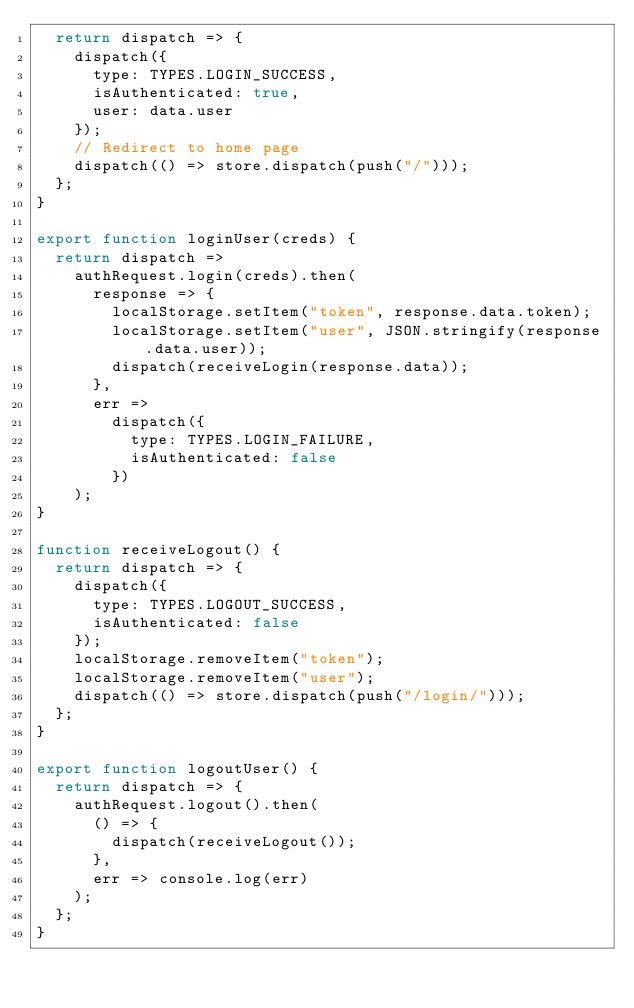<code> <loc_0><loc_0><loc_500><loc_500><_JavaScript_>  return dispatch => {
    dispatch({
      type: TYPES.LOGIN_SUCCESS,
      isAuthenticated: true,
      user: data.user
    });
    // Redirect to home page
    dispatch(() => store.dispatch(push("/")));
  };
}

export function loginUser(creds) {
  return dispatch =>
    authRequest.login(creds).then(
      response => {
        localStorage.setItem("token", response.data.token);
        localStorage.setItem("user", JSON.stringify(response.data.user));
        dispatch(receiveLogin(response.data));
      },
      err =>
        dispatch({
          type: TYPES.LOGIN_FAILURE,
          isAuthenticated: false
        })
    );
}

function receiveLogout() {
  return dispatch => {
    dispatch({
      type: TYPES.LOGOUT_SUCCESS,
      isAuthenticated: false
    });
    localStorage.removeItem("token");
    localStorage.removeItem("user");
    dispatch(() => store.dispatch(push("/login/")));
  };
}

export function logoutUser() {
  return dispatch => {
    authRequest.logout().then(
      () => {
        dispatch(receiveLogout());
      },
      err => console.log(err)
    );
  };
}
</code> 